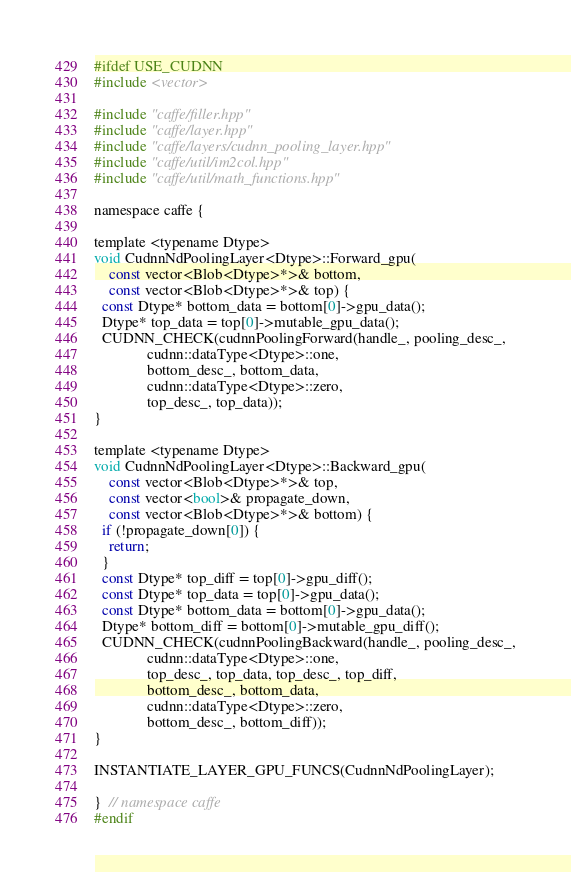<code> <loc_0><loc_0><loc_500><loc_500><_Cuda_>#ifdef USE_CUDNN
#include <vector>

#include "caffe/filler.hpp"
#include "caffe/layer.hpp"
#include "caffe/layers/cudnn_pooling_layer.hpp"
#include "caffe/util/im2col.hpp"
#include "caffe/util/math_functions.hpp"

namespace caffe {

template <typename Dtype>
void CudnnNdPoolingLayer<Dtype>::Forward_gpu(
    const vector<Blob<Dtype>*>& bottom,
    const vector<Blob<Dtype>*>& top) {
  const Dtype* bottom_data = bottom[0]->gpu_data();
  Dtype* top_data = top[0]->mutable_gpu_data();
  CUDNN_CHECK(cudnnPoolingForward(handle_, pooling_desc_,
              cudnn::dataType<Dtype>::one,
              bottom_desc_, bottom_data,
              cudnn::dataType<Dtype>::zero,
              top_desc_, top_data));
}

template <typename Dtype>
void CudnnNdPoolingLayer<Dtype>::Backward_gpu(
    const vector<Blob<Dtype>*>& top,
    const vector<bool>& propagate_down,
    const vector<Blob<Dtype>*>& bottom) {
  if (!propagate_down[0]) {
    return;
  }
  const Dtype* top_diff = top[0]->gpu_diff();
  const Dtype* top_data = top[0]->gpu_data();
  const Dtype* bottom_data = bottom[0]->gpu_data();
  Dtype* bottom_diff = bottom[0]->mutable_gpu_diff();
  CUDNN_CHECK(cudnnPoolingBackward(handle_, pooling_desc_,
              cudnn::dataType<Dtype>::one,
              top_desc_, top_data, top_desc_, top_diff,
              bottom_desc_, bottom_data,
              cudnn::dataType<Dtype>::zero,
              bottom_desc_, bottom_diff));
}

INSTANTIATE_LAYER_GPU_FUNCS(CudnnNdPoolingLayer);

}  // namespace caffe
#endif
</code> 